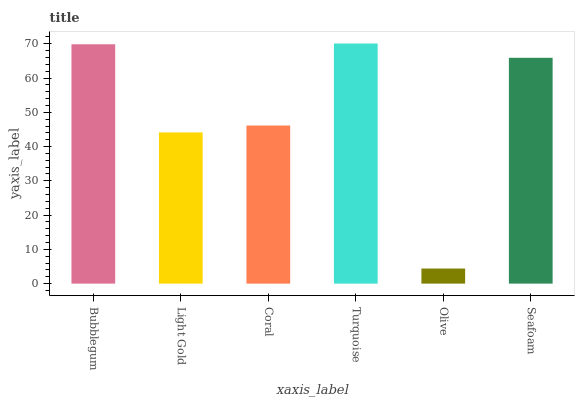Is Olive the minimum?
Answer yes or no. Yes. Is Turquoise the maximum?
Answer yes or no. Yes. Is Light Gold the minimum?
Answer yes or no. No. Is Light Gold the maximum?
Answer yes or no. No. Is Bubblegum greater than Light Gold?
Answer yes or no. Yes. Is Light Gold less than Bubblegum?
Answer yes or no. Yes. Is Light Gold greater than Bubblegum?
Answer yes or no. No. Is Bubblegum less than Light Gold?
Answer yes or no. No. Is Seafoam the high median?
Answer yes or no. Yes. Is Coral the low median?
Answer yes or no. Yes. Is Light Gold the high median?
Answer yes or no. No. Is Light Gold the low median?
Answer yes or no. No. 